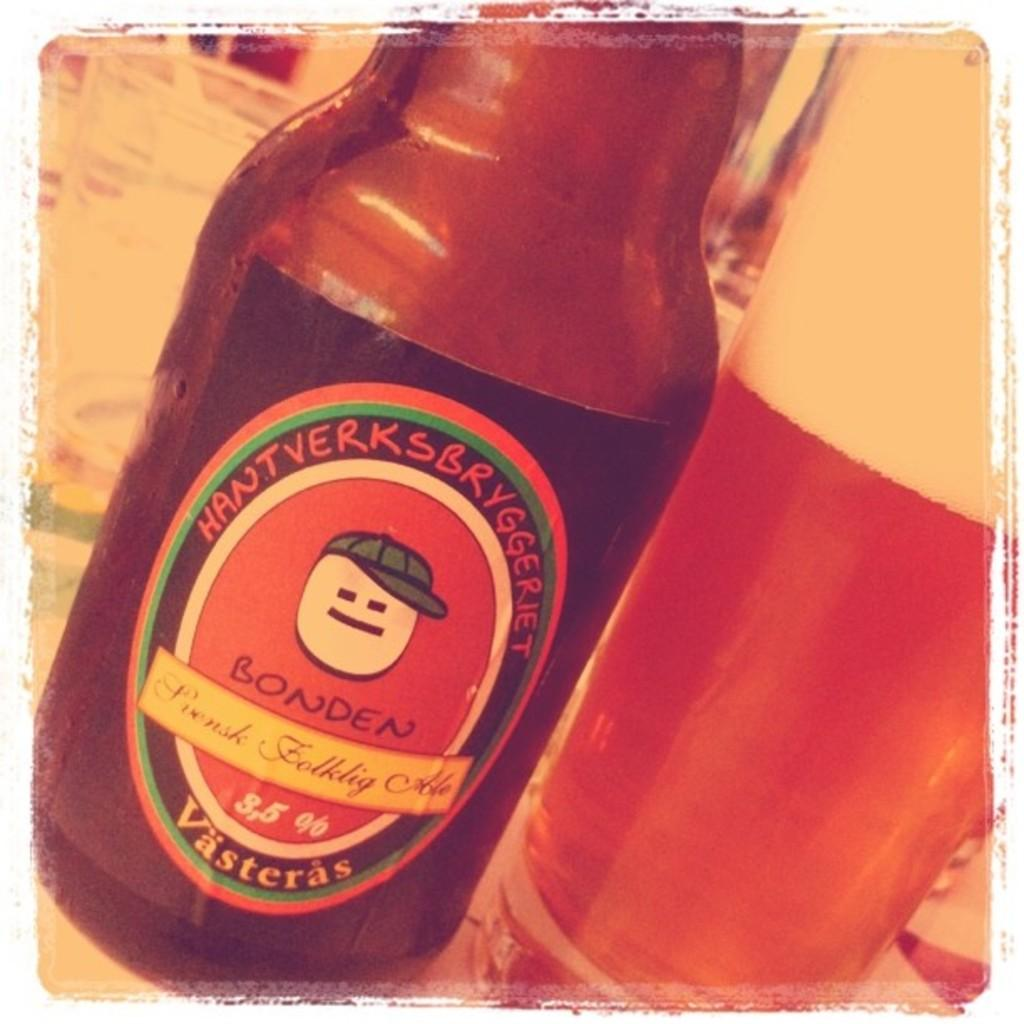<image>
Share a concise interpretation of the image provided. a bottle of hantverksbryggerjet bonden vasteras standing next to a glass full of i 